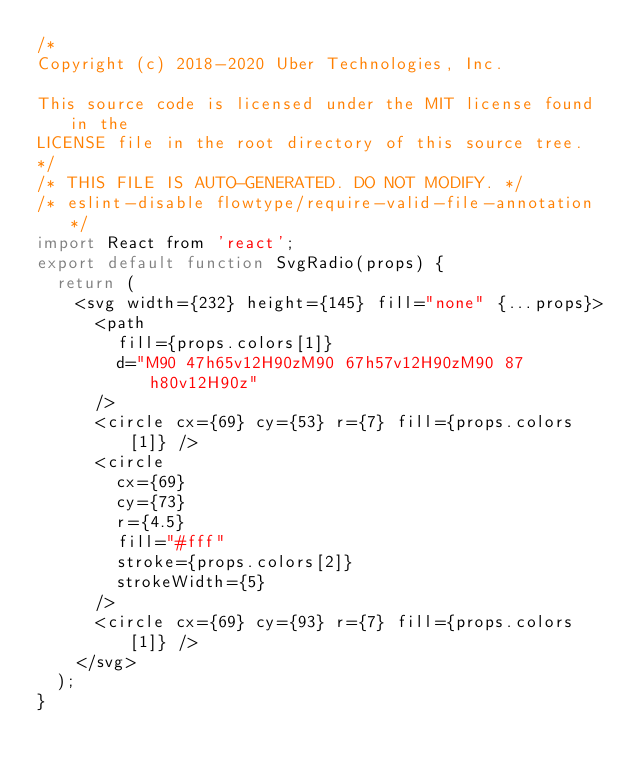Convert code to text. <code><loc_0><loc_0><loc_500><loc_500><_JavaScript_>/*
Copyright (c) 2018-2020 Uber Technologies, Inc.

This source code is licensed under the MIT license found in the
LICENSE file in the root directory of this source tree.
*/
/* THIS FILE IS AUTO-GENERATED. DO NOT MODIFY. */
/* eslint-disable flowtype/require-valid-file-annotation */
import React from 'react';
export default function SvgRadio(props) {
  return (
    <svg width={232} height={145} fill="none" {...props}>
      <path
        fill={props.colors[1]}
        d="M90 47h65v12H90zM90 67h57v12H90zM90 87h80v12H90z"
      />
      <circle cx={69} cy={53} r={7} fill={props.colors[1]} />
      <circle
        cx={69}
        cy={73}
        r={4.5}
        fill="#fff"
        stroke={props.colors[2]}
        strokeWidth={5}
      />
      <circle cx={69} cy={93} r={7} fill={props.colors[1]} />
    </svg>
  );
}
</code> 